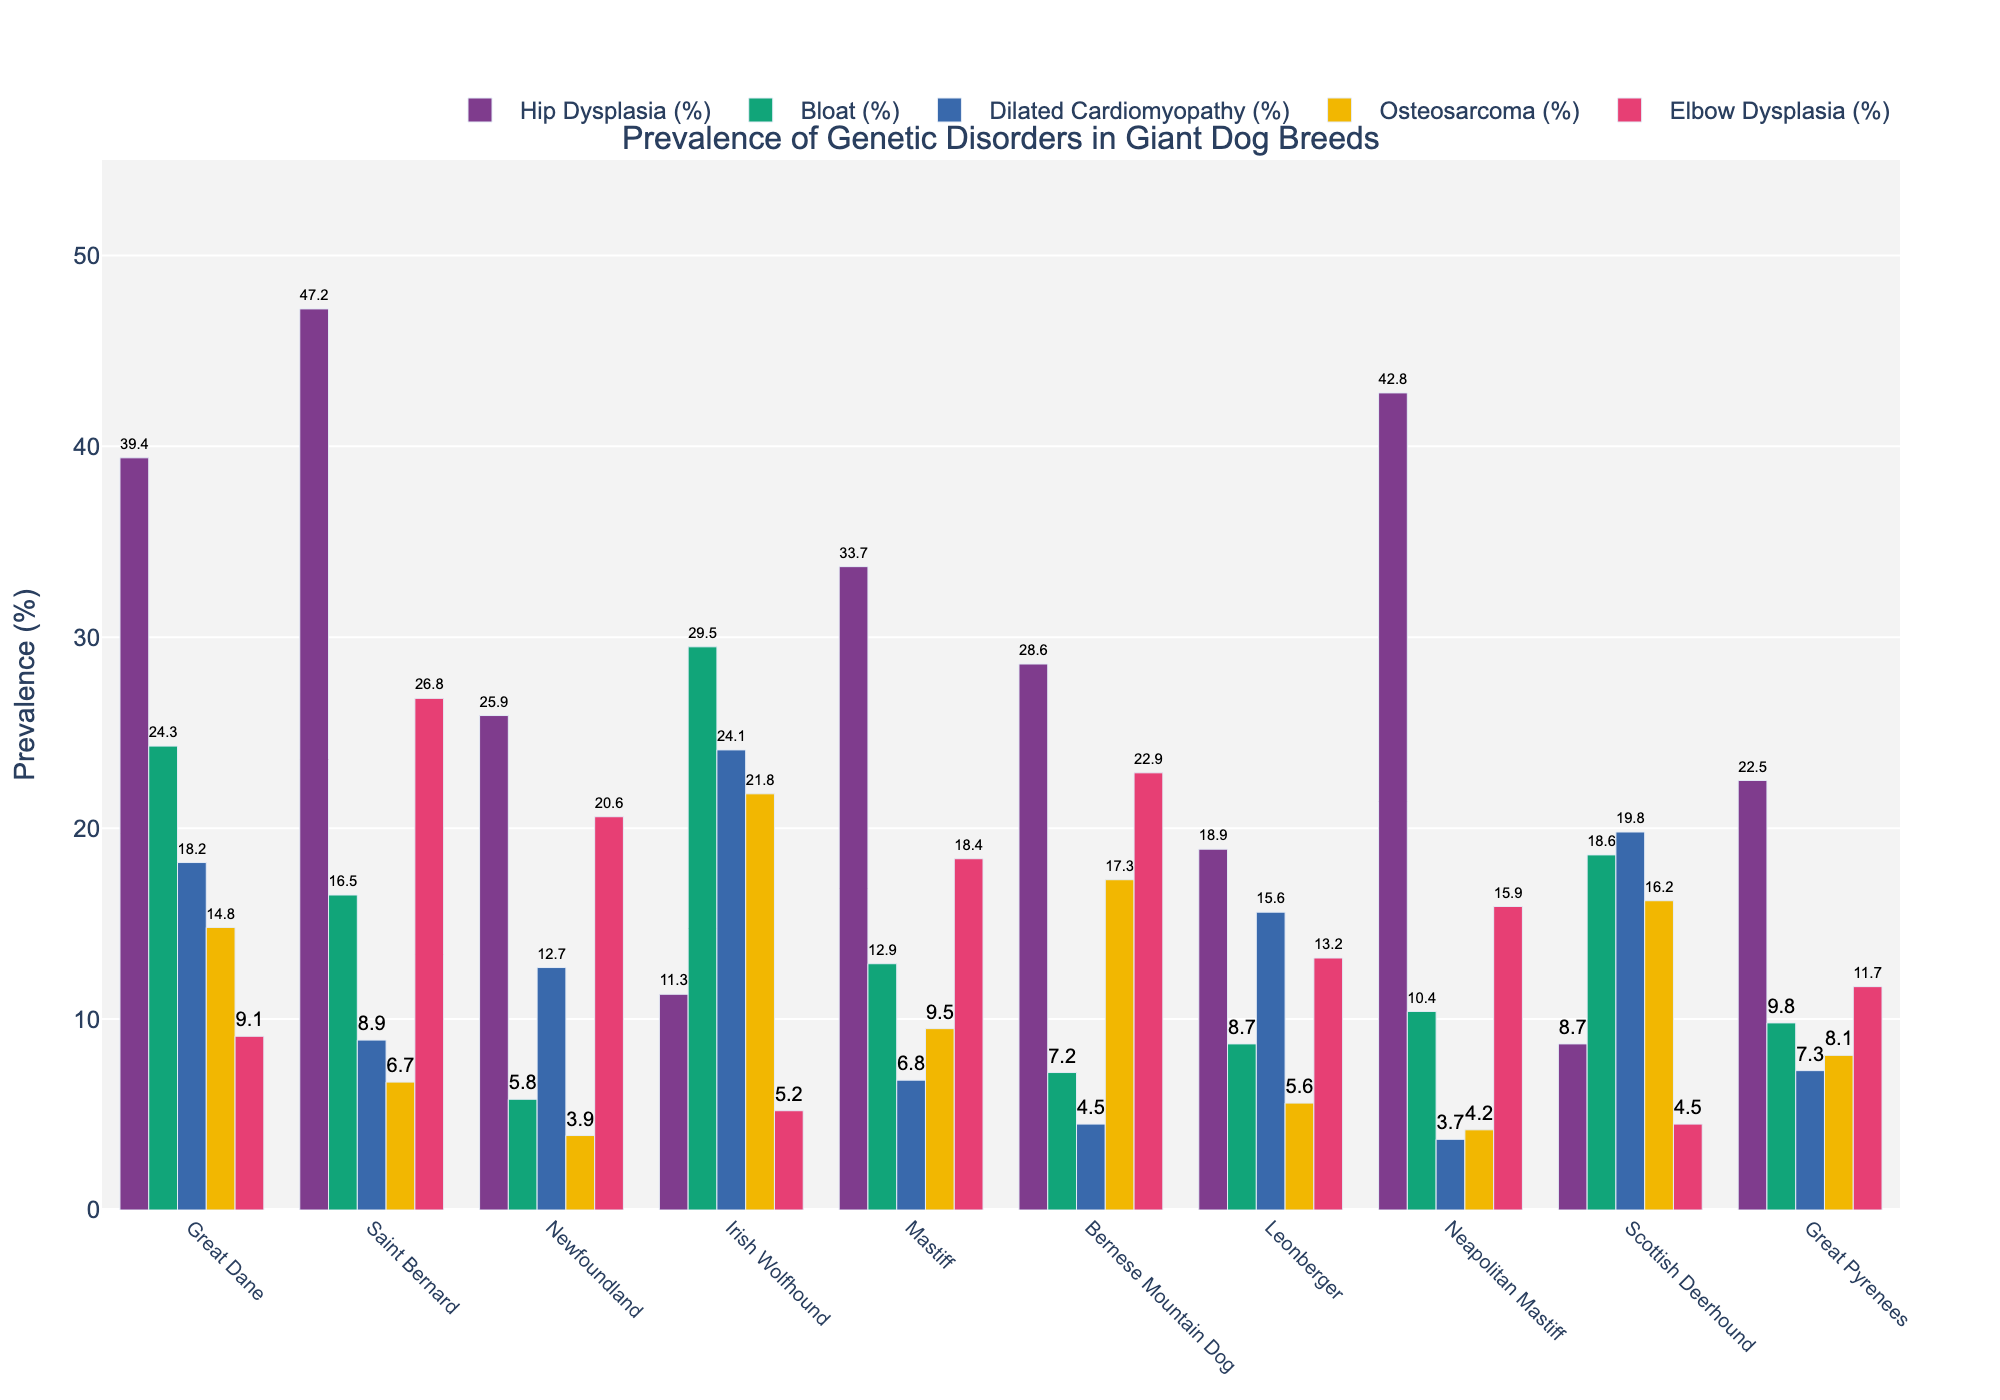What breed has the highest prevalence of hip dysplasia? Observe the bars representing hip dysplasia for all breeds. The bar for Saint Bernard is the highest, indicating it has the highest prevalence of hip dysplasia.
Answer: Saint Bernard Which breed shows the lowest prevalence of dilated cardiomyopathy? Look at the bars representing dilated cardiomyopathy across all breeds. The Neapolitan Mastiff has the shortest bar, showing the lowest prevalence of this disorder.
Answer: Neapolitan Mastiff How does the prevalence of elbow dysplasia in the Newfoundland compare to that in Mastiff? Compare the heights of the bars for elbow dysplasia between Newfoundland and Mastiff. The bar for Newfoundland is higher than the bar for Mastiff.
Answer: Higher Which breeds have a higher prevalence of bloat than Great Danes? Identify the bar corresponding to bloat for Great Danes, then look for bars of other breeds that are taller. Only the Irish Wolfhound has a higher prevalence.
Answer: Irish Wolfhound What is the average prevalence of osteosarcoma across all breeds? Identify the prevalence values for osteosarcoma for each breed, sum them up, and then divide by the number of breeds: (14.8 + 6.7 + 3.9 + 21.8 + 9.5 + 17.3 + 5.6 + 4.2 + 16.2 + 8.1) / 10 = 10.81.
Answer: 10.81% Which genetic disorder in the Great Dane has the lowest prevalence? Look at all the bars for the Great Dane and identify the shortest one, which corresponds to elbow dysplasia.
Answer: Elbow Dysplasia What is the combined prevalence of hip dysplasia and elbow dysplasia in Leonberger? Find the bars for hip dysplasia and elbow dysplasia for Leonberger and sum their values: 18.9 + 13.2 = 32.1.
Answer: 32.1% How does the prevalence of bloat in Saint Bernard compare to that in Neapolitan Mastiff? Compare the bars representing bloat for Saint Bernard and Neapolitan Mastiff. The bar for Saint Bernard is taller, indicating a higher prevalence.
Answer: Higher Which breed has the second highest prevalence of hip dysplasia? Identify the bar with the second largest value for hip dysplasia after Saint Bernard; it is the Neapolitan Mastiff.
Answer: Neapolitan Mastiff 